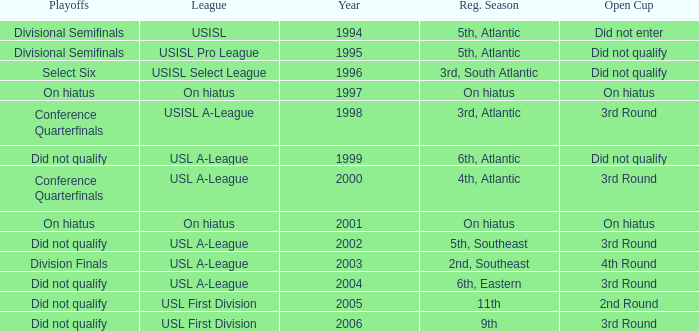Parse the full table. {'header': ['Playoffs', 'League', 'Year', 'Reg. Season', 'Open Cup'], 'rows': [['Divisional Semifinals', 'USISL', '1994', '5th, Atlantic', 'Did not enter'], ['Divisional Semifinals', 'USISL Pro League', '1995', '5th, Atlantic', 'Did not qualify'], ['Select Six', 'USISL Select League', '1996', '3rd, South Atlantic', 'Did not qualify'], ['On hiatus', 'On hiatus', '1997', 'On hiatus', 'On hiatus'], ['Conference Quarterfinals', 'USISL A-League', '1998', '3rd, Atlantic', '3rd Round'], ['Did not qualify', 'USL A-League', '1999', '6th, Atlantic', 'Did not qualify'], ['Conference Quarterfinals', 'USL A-League', '2000', '4th, Atlantic', '3rd Round'], ['On hiatus', 'On hiatus', '2001', 'On hiatus', 'On hiatus'], ['Did not qualify', 'USL A-League', '2002', '5th, Southeast', '3rd Round'], ['Division Finals', 'USL A-League', '2003', '2nd, Southeast', '4th Round'], ['Did not qualify', 'USL A-League', '2004', '6th, Eastern', '3rd Round'], ['Did not qualify', 'USL First Division', '2005', '11th', '2nd Round'], ['Did not qualify', 'USL First Division', '2006', '9th', '3rd Round']]} What was the earliest year for the USISL Pro League? 1995.0. 